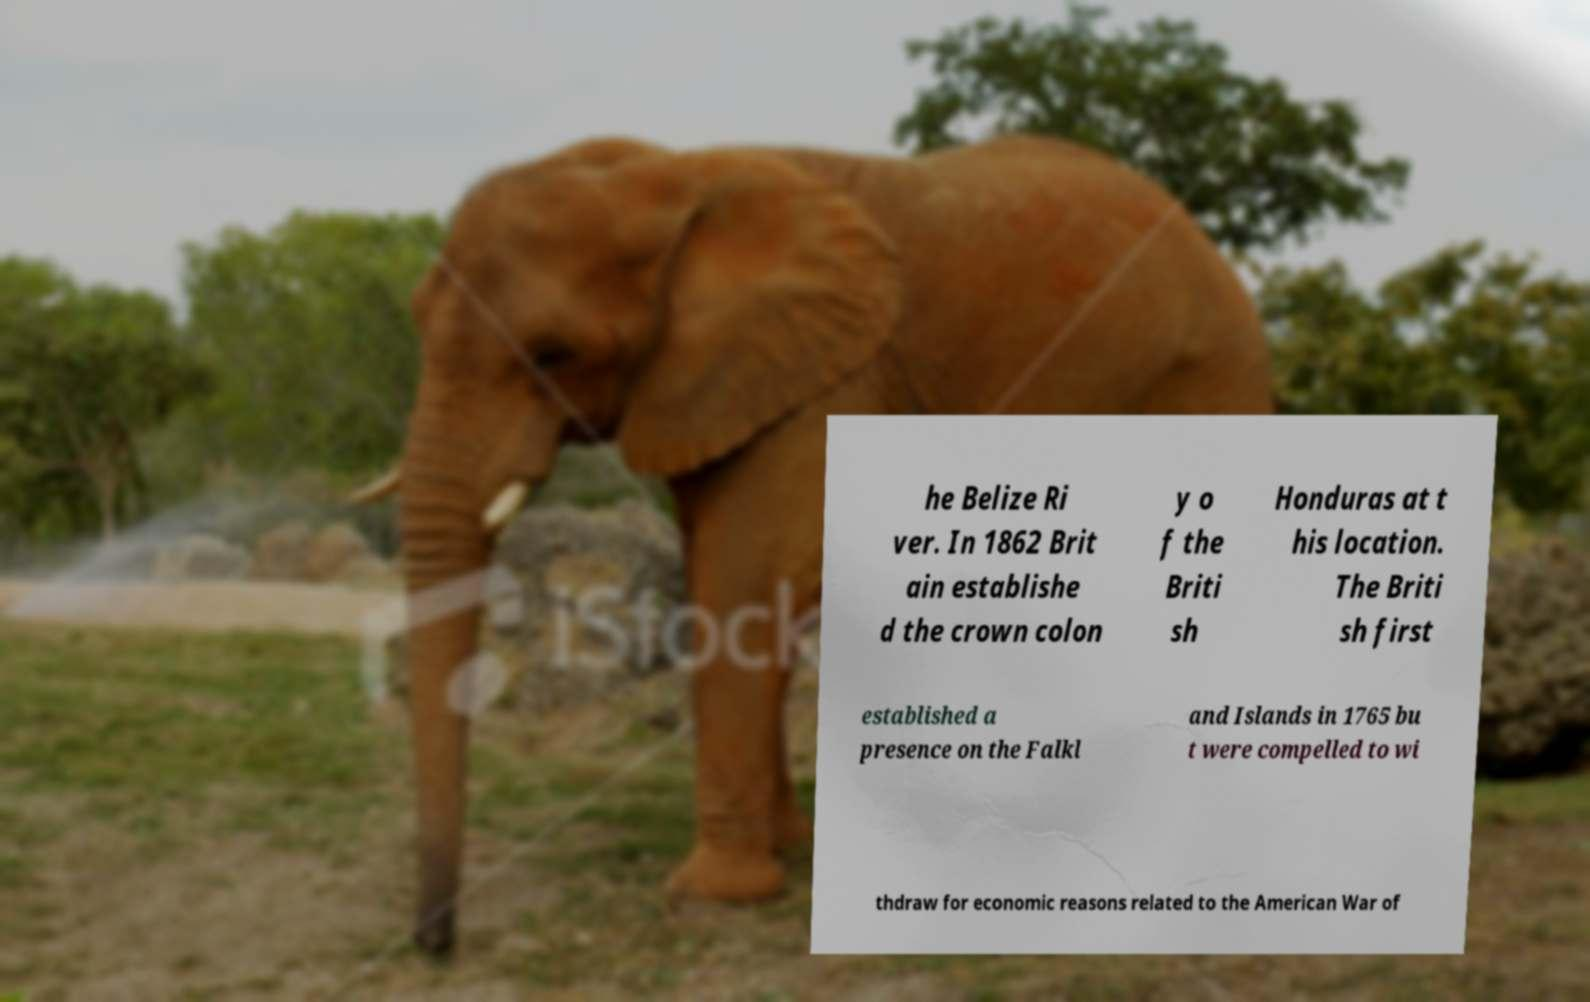For documentation purposes, I need the text within this image transcribed. Could you provide that? he Belize Ri ver. In 1862 Brit ain establishe d the crown colon y o f the Briti sh Honduras at t his location. The Briti sh first established a presence on the Falkl and Islands in 1765 bu t were compelled to wi thdraw for economic reasons related to the American War of 